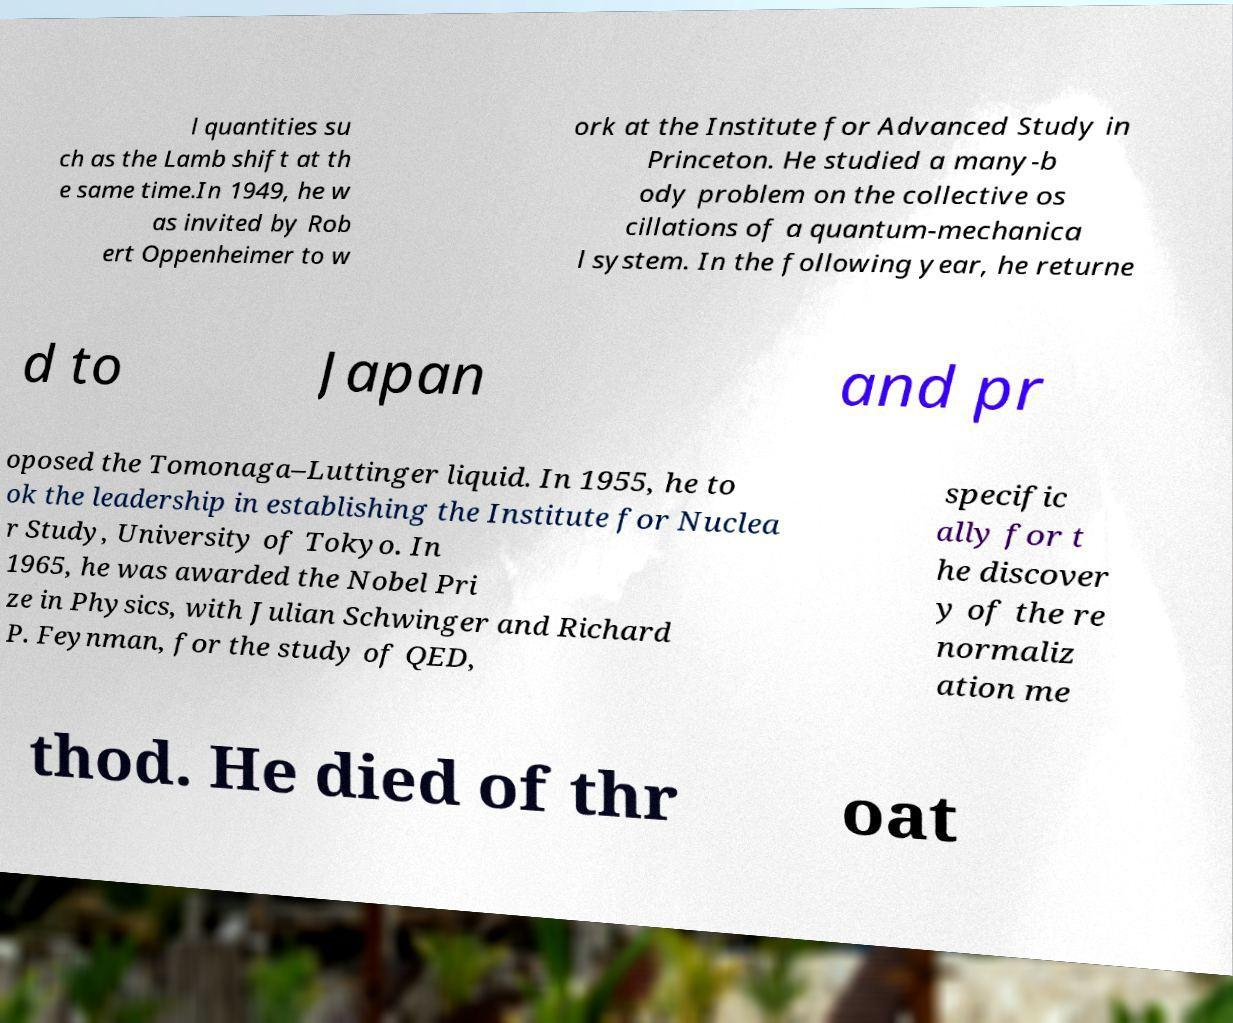For documentation purposes, I need the text within this image transcribed. Could you provide that? l quantities su ch as the Lamb shift at th e same time.In 1949, he w as invited by Rob ert Oppenheimer to w ork at the Institute for Advanced Study in Princeton. He studied a many-b ody problem on the collective os cillations of a quantum-mechanica l system. In the following year, he returne d to Japan and pr oposed the Tomonaga–Luttinger liquid. In 1955, he to ok the leadership in establishing the Institute for Nuclea r Study, University of Tokyo. In 1965, he was awarded the Nobel Pri ze in Physics, with Julian Schwinger and Richard P. Feynman, for the study of QED, specific ally for t he discover y of the re normaliz ation me thod. He died of thr oat 